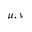Convert formula to latex. <formula><loc_0><loc_0><loc_500><loc_500>\mu , \nu</formula> 